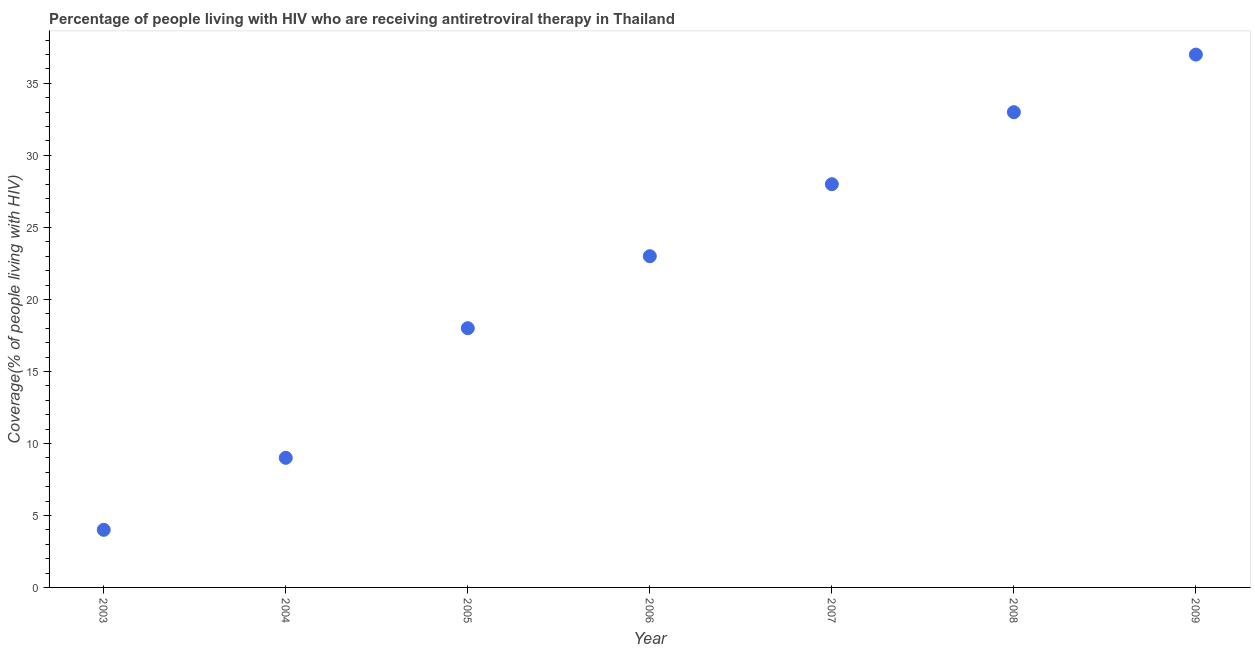What is the antiretroviral therapy coverage in 2003?
Make the answer very short. 4. Across all years, what is the maximum antiretroviral therapy coverage?
Your response must be concise. 37. Across all years, what is the minimum antiretroviral therapy coverage?
Offer a very short reply. 4. In which year was the antiretroviral therapy coverage maximum?
Make the answer very short. 2009. In which year was the antiretroviral therapy coverage minimum?
Provide a short and direct response. 2003. What is the sum of the antiretroviral therapy coverage?
Give a very brief answer. 152. What is the difference between the antiretroviral therapy coverage in 2005 and 2009?
Your answer should be compact. -19. What is the average antiretroviral therapy coverage per year?
Provide a short and direct response. 21.71. In how many years, is the antiretroviral therapy coverage greater than 32 %?
Your response must be concise. 2. Do a majority of the years between 2009 and 2008 (inclusive) have antiretroviral therapy coverage greater than 3 %?
Your answer should be compact. No. What is the ratio of the antiretroviral therapy coverage in 2005 to that in 2006?
Offer a terse response. 0.78. Is the antiretroviral therapy coverage in 2003 less than that in 2008?
Your answer should be very brief. Yes. Is the sum of the antiretroviral therapy coverage in 2005 and 2008 greater than the maximum antiretroviral therapy coverage across all years?
Provide a short and direct response. Yes. What is the difference between the highest and the lowest antiretroviral therapy coverage?
Make the answer very short. 33. In how many years, is the antiretroviral therapy coverage greater than the average antiretroviral therapy coverage taken over all years?
Your answer should be very brief. 4. How many dotlines are there?
Make the answer very short. 1. What is the difference between two consecutive major ticks on the Y-axis?
Your answer should be very brief. 5. What is the title of the graph?
Your answer should be very brief. Percentage of people living with HIV who are receiving antiretroviral therapy in Thailand. What is the label or title of the Y-axis?
Your answer should be compact. Coverage(% of people living with HIV). What is the Coverage(% of people living with HIV) in 2003?
Keep it short and to the point. 4. What is the Coverage(% of people living with HIV) in 2005?
Give a very brief answer. 18. What is the Coverage(% of people living with HIV) in 2007?
Your answer should be compact. 28. What is the Coverage(% of people living with HIV) in 2008?
Your answer should be compact. 33. What is the difference between the Coverage(% of people living with HIV) in 2003 and 2007?
Provide a short and direct response. -24. What is the difference between the Coverage(% of people living with HIV) in 2003 and 2008?
Keep it short and to the point. -29. What is the difference between the Coverage(% of people living with HIV) in 2003 and 2009?
Provide a short and direct response. -33. What is the difference between the Coverage(% of people living with HIV) in 2004 and 2005?
Ensure brevity in your answer.  -9. What is the difference between the Coverage(% of people living with HIV) in 2004 and 2006?
Your response must be concise. -14. What is the difference between the Coverage(% of people living with HIV) in 2005 and 2007?
Offer a very short reply. -10. What is the difference between the Coverage(% of people living with HIV) in 2005 and 2008?
Ensure brevity in your answer.  -15. What is the difference between the Coverage(% of people living with HIV) in 2006 and 2007?
Your answer should be very brief. -5. What is the difference between the Coverage(% of people living with HIV) in 2006 and 2008?
Ensure brevity in your answer.  -10. What is the difference between the Coverage(% of people living with HIV) in 2006 and 2009?
Provide a succinct answer. -14. What is the ratio of the Coverage(% of people living with HIV) in 2003 to that in 2004?
Your response must be concise. 0.44. What is the ratio of the Coverage(% of people living with HIV) in 2003 to that in 2005?
Provide a short and direct response. 0.22. What is the ratio of the Coverage(% of people living with HIV) in 2003 to that in 2006?
Your response must be concise. 0.17. What is the ratio of the Coverage(% of people living with HIV) in 2003 to that in 2007?
Your response must be concise. 0.14. What is the ratio of the Coverage(% of people living with HIV) in 2003 to that in 2008?
Your response must be concise. 0.12. What is the ratio of the Coverage(% of people living with HIV) in 2003 to that in 2009?
Your answer should be very brief. 0.11. What is the ratio of the Coverage(% of people living with HIV) in 2004 to that in 2005?
Your answer should be compact. 0.5. What is the ratio of the Coverage(% of people living with HIV) in 2004 to that in 2006?
Keep it short and to the point. 0.39. What is the ratio of the Coverage(% of people living with HIV) in 2004 to that in 2007?
Give a very brief answer. 0.32. What is the ratio of the Coverage(% of people living with HIV) in 2004 to that in 2008?
Offer a very short reply. 0.27. What is the ratio of the Coverage(% of people living with HIV) in 2004 to that in 2009?
Your answer should be compact. 0.24. What is the ratio of the Coverage(% of people living with HIV) in 2005 to that in 2006?
Provide a short and direct response. 0.78. What is the ratio of the Coverage(% of people living with HIV) in 2005 to that in 2007?
Ensure brevity in your answer.  0.64. What is the ratio of the Coverage(% of people living with HIV) in 2005 to that in 2008?
Make the answer very short. 0.55. What is the ratio of the Coverage(% of people living with HIV) in 2005 to that in 2009?
Provide a short and direct response. 0.49. What is the ratio of the Coverage(% of people living with HIV) in 2006 to that in 2007?
Give a very brief answer. 0.82. What is the ratio of the Coverage(% of people living with HIV) in 2006 to that in 2008?
Your answer should be compact. 0.7. What is the ratio of the Coverage(% of people living with HIV) in 2006 to that in 2009?
Your answer should be very brief. 0.62. What is the ratio of the Coverage(% of people living with HIV) in 2007 to that in 2008?
Your answer should be very brief. 0.85. What is the ratio of the Coverage(% of people living with HIV) in 2007 to that in 2009?
Make the answer very short. 0.76. What is the ratio of the Coverage(% of people living with HIV) in 2008 to that in 2009?
Provide a short and direct response. 0.89. 